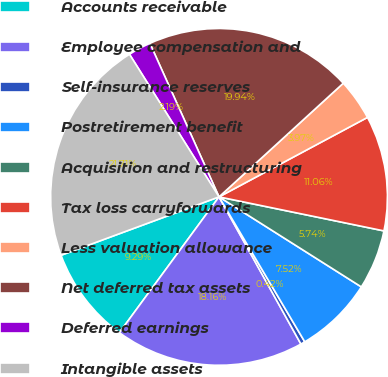Convert chart. <chart><loc_0><loc_0><loc_500><loc_500><pie_chart><fcel>Accounts receivable<fcel>Employee compensation and<fcel>Self-insurance reserves<fcel>Postretirement benefit<fcel>Acquisition and restructuring<fcel>Tax loss carryforwards<fcel>Less valuation allowance<fcel>Net deferred tax assets<fcel>Deferred earnings<fcel>Intangible assets<nl><fcel>9.29%<fcel>18.16%<fcel>0.42%<fcel>7.52%<fcel>5.74%<fcel>11.06%<fcel>3.97%<fcel>19.94%<fcel>2.19%<fcel>21.71%<nl></chart> 